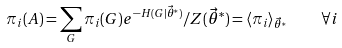<formula> <loc_0><loc_0><loc_500><loc_500>\pi _ { i } ( A ) = \sum _ { G } \pi _ { i } ( G ) e ^ { - H ( G | \vec { \theta } ^ { * } ) } / Z ( \vec { \theta } ^ { * } ) = \langle \pi _ { i } \rangle _ { \vec { \theta } ^ { * } } \quad \forall i</formula> 